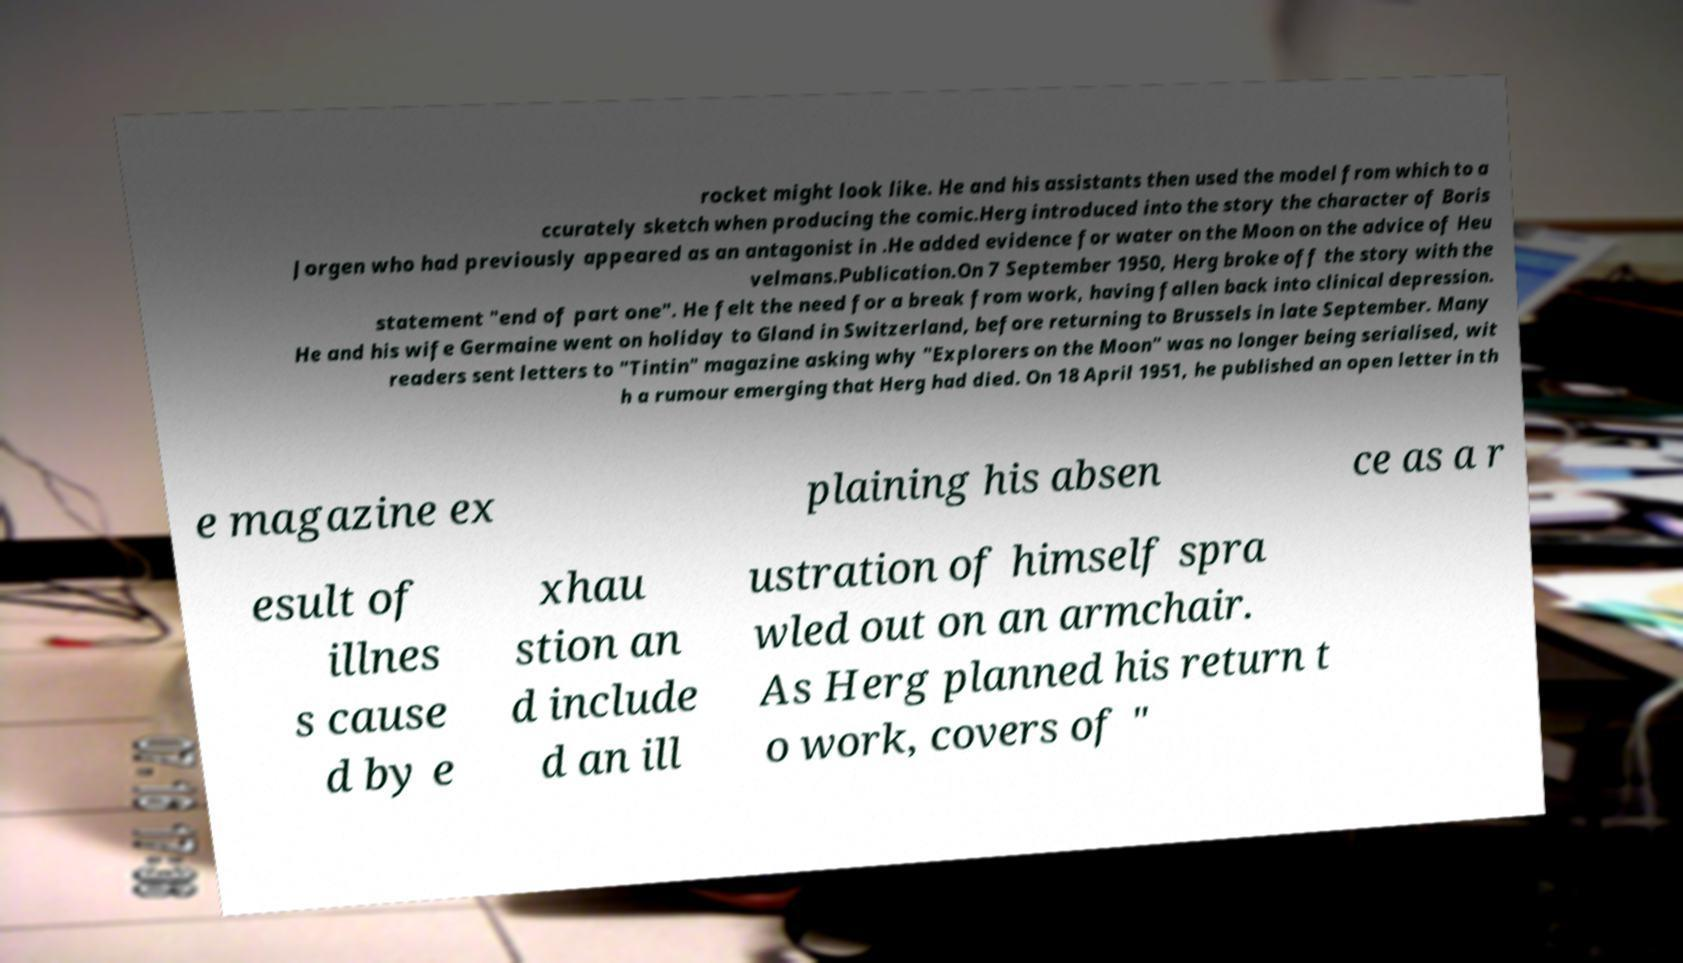Can you read and provide the text displayed in the image?This photo seems to have some interesting text. Can you extract and type it out for me? rocket might look like. He and his assistants then used the model from which to a ccurately sketch when producing the comic.Herg introduced into the story the character of Boris Jorgen who had previously appeared as an antagonist in .He added evidence for water on the Moon on the advice of Heu velmans.Publication.On 7 September 1950, Herg broke off the story with the statement "end of part one". He felt the need for a break from work, having fallen back into clinical depression. He and his wife Germaine went on holiday to Gland in Switzerland, before returning to Brussels in late September. Many readers sent letters to "Tintin" magazine asking why "Explorers on the Moon" was no longer being serialised, wit h a rumour emerging that Herg had died. On 18 April 1951, he published an open letter in th e magazine ex plaining his absen ce as a r esult of illnes s cause d by e xhau stion an d include d an ill ustration of himself spra wled out on an armchair. As Herg planned his return t o work, covers of " 